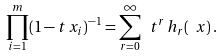Convert formula to latex. <formula><loc_0><loc_0><loc_500><loc_500>\prod _ { i = 1 } ^ { m } ( 1 - t \, x _ { i } ) ^ { - 1 } = \sum _ { r = 0 } ^ { \infty } \ t ^ { r } \, h _ { r } ( \ x ) \, .</formula> 